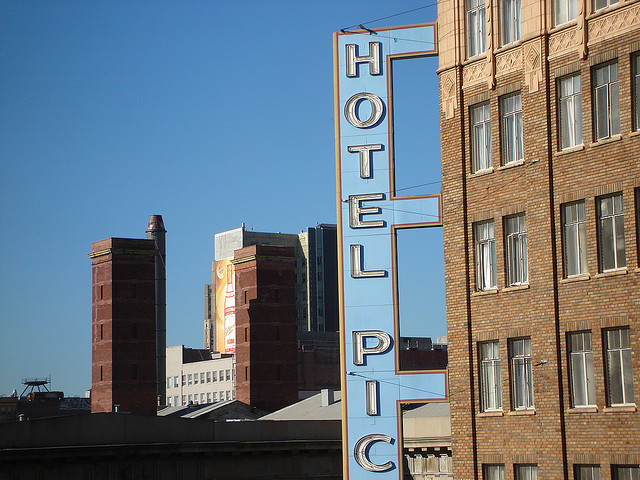Identify the text contained in this image. HOTEL PIC 